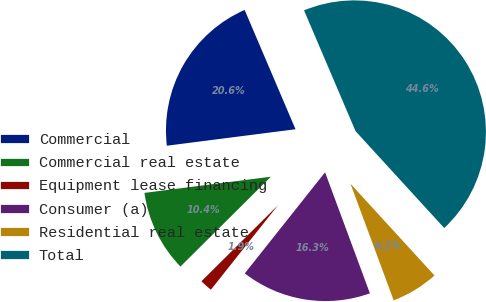Convert chart. <chart><loc_0><loc_0><loc_500><loc_500><pie_chart><fcel>Commercial<fcel>Commercial real estate<fcel>Equipment lease financing<fcel>Consumer (a)<fcel>Residential real estate<fcel>Total<nl><fcel>20.61%<fcel>10.42%<fcel>1.87%<fcel>16.33%<fcel>6.15%<fcel>44.62%<nl></chart> 